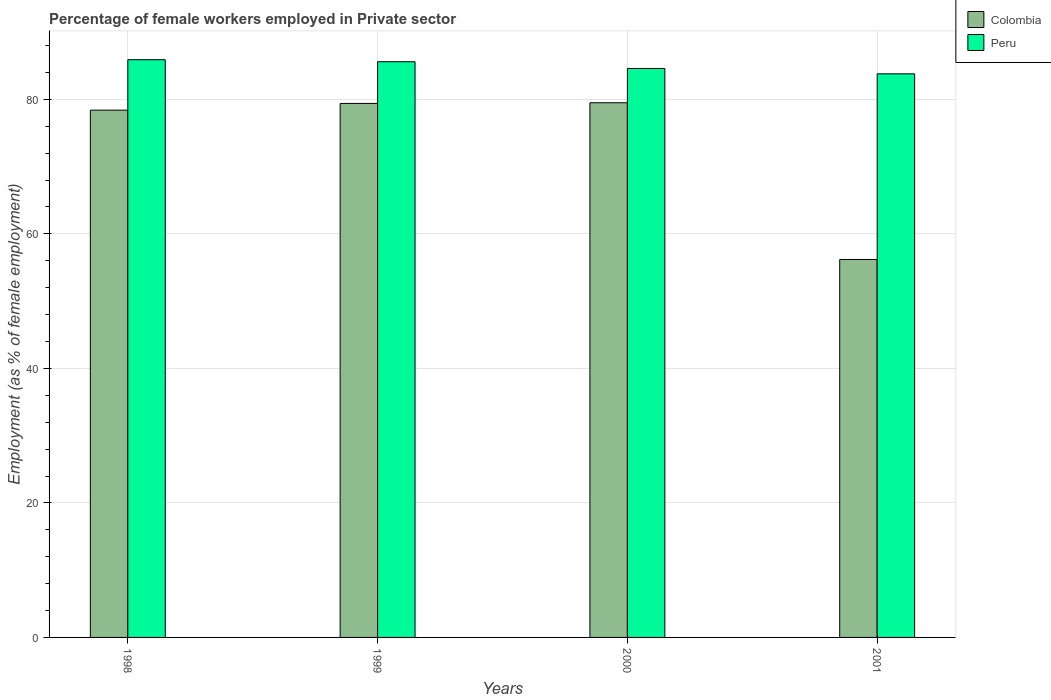How many different coloured bars are there?
Make the answer very short. 2. How many groups of bars are there?
Ensure brevity in your answer.  4. What is the label of the 3rd group of bars from the left?
Offer a very short reply. 2000. What is the percentage of females employed in Private sector in Peru in 2001?
Offer a very short reply. 83.8. Across all years, what is the maximum percentage of females employed in Private sector in Peru?
Offer a terse response. 85.9. Across all years, what is the minimum percentage of females employed in Private sector in Colombia?
Offer a terse response. 56.2. In which year was the percentage of females employed in Private sector in Peru maximum?
Provide a succinct answer. 1998. What is the total percentage of females employed in Private sector in Peru in the graph?
Offer a very short reply. 339.9. What is the difference between the percentage of females employed in Private sector in Colombia in 2000 and that in 2001?
Ensure brevity in your answer.  23.3. What is the difference between the percentage of females employed in Private sector in Colombia in 2001 and the percentage of females employed in Private sector in Peru in 1999?
Provide a succinct answer. -29.4. What is the average percentage of females employed in Private sector in Peru per year?
Give a very brief answer. 84.98. In the year 2000, what is the difference between the percentage of females employed in Private sector in Colombia and percentage of females employed in Private sector in Peru?
Provide a short and direct response. -5.1. In how many years, is the percentage of females employed in Private sector in Peru greater than 24 %?
Provide a short and direct response. 4. What is the ratio of the percentage of females employed in Private sector in Colombia in 1999 to that in 2001?
Give a very brief answer. 1.41. Is the percentage of females employed in Private sector in Colombia in 1999 less than that in 2001?
Provide a succinct answer. No. Is the difference between the percentage of females employed in Private sector in Colombia in 1998 and 2001 greater than the difference between the percentage of females employed in Private sector in Peru in 1998 and 2001?
Your answer should be compact. Yes. What is the difference between the highest and the second highest percentage of females employed in Private sector in Colombia?
Your answer should be compact. 0.1. What is the difference between the highest and the lowest percentage of females employed in Private sector in Colombia?
Offer a very short reply. 23.3. In how many years, is the percentage of females employed in Private sector in Colombia greater than the average percentage of females employed in Private sector in Colombia taken over all years?
Make the answer very short. 3. Is the sum of the percentage of females employed in Private sector in Peru in 2000 and 2001 greater than the maximum percentage of females employed in Private sector in Colombia across all years?
Your answer should be compact. Yes. What does the 2nd bar from the left in 2000 represents?
Offer a very short reply. Peru. How many years are there in the graph?
Provide a short and direct response. 4. How many legend labels are there?
Make the answer very short. 2. What is the title of the graph?
Keep it short and to the point. Percentage of female workers employed in Private sector. Does "Guyana" appear as one of the legend labels in the graph?
Provide a short and direct response. No. What is the label or title of the Y-axis?
Provide a short and direct response. Employment (as % of female employment). What is the Employment (as % of female employment) of Colombia in 1998?
Your answer should be very brief. 78.4. What is the Employment (as % of female employment) in Peru in 1998?
Make the answer very short. 85.9. What is the Employment (as % of female employment) in Colombia in 1999?
Provide a succinct answer. 79.4. What is the Employment (as % of female employment) in Peru in 1999?
Ensure brevity in your answer.  85.6. What is the Employment (as % of female employment) in Colombia in 2000?
Ensure brevity in your answer.  79.5. What is the Employment (as % of female employment) in Peru in 2000?
Provide a short and direct response. 84.6. What is the Employment (as % of female employment) of Colombia in 2001?
Keep it short and to the point. 56.2. What is the Employment (as % of female employment) of Peru in 2001?
Ensure brevity in your answer.  83.8. Across all years, what is the maximum Employment (as % of female employment) in Colombia?
Make the answer very short. 79.5. Across all years, what is the maximum Employment (as % of female employment) of Peru?
Offer a terse response. 85.9. Across all years, what is the minimum Employment (as % of female employment) in Colombia?
Provide a short and direct response. 56.2. Across all years, what is the minimum Employment (as % of female employment) in Peru?
Offer a terse response. 83.8. What is the total Employment (as % of female employment) in Colombia in the graph?
Keep it short and to the point. 293.5. What is the total Employment (as % of female employment) of Peru in the graph?
Your answer should be very brief. 339.9. What is the difference between the Employment (as % of female employment) in Peru in 1998 and that in 1999?
Give a very brief answer. 0.3. What is the difference between the Employment (as % of female employment) in Peru in 1998 and that in 2001?
Offer a very short reply. 2.1. What is the difference between the Employment (as % of female employment) in Colombia in 1999 and that in 2000?
Your answer should be compact. -0.1. What is the difference between the Employment (as % of female employment) in Peru in 1999 and that in 2000?
Offer a very short reply. 1. What is the difference between the Employment (as % of female employment) in Colombia in 1999 and that in 2001?
Provide a succinct answer. 23.2. What is the difference between the Employment (as % of female employment) of Colombia in 2000 and that in 2001?
Provide a succinct answer. 23.3. What is the difference between the Employment (as % of female employment) in Colombia in 1998 and the Employment (as % of female employment) in Peru in 2000?
Give a very brief answer. -6.2. What is the difference between the Employment (as % of female employment) of Colombia in 1998 and the Employment (as % of female employment) of Peru in 2001?
Offer a terse response. -5.4. What is the difference between the Employment (as % of female employment) of Colombia in 1999 and the Employment (as % of female employment) of Peru in 2001?
Keep it short and to the point. -4.4. What is the average Employment (as % of female employment) in Colombia per year?
Offer a very short reply. 73.38. What is the average Employment (as % of female employment) of Peru per year?
Your response must be concise. 84.97. In the year 1998, what is the difference between the Employment (as % of female employment) in Colombia and Employment (as % of female employment) in Peru?
Keep it short and to the point. -7.5. In the year 2000, what is the difference between the Employment (as % of female employment) of Colombia and Employment (as % of female employment) of Peru?
Ensure brevity in your answer.  -5.1. In the year 2001, what is the difference between the Employment (as % of female employment) of Colombia and Employment (as % of female employment) of Peru?
Ensure brevity in your answer.  -27.6. What is the ratio of the Employment (as % of female employment) of Colombia in 1998 to that in 1999?
Offer a terse response. 0.99. What is the ratio of the Employment (as % of female employment) of Colombia in 1998 to that in 2000?
Offer a terse response. 0.99. What is the ratio of the Employment (as % of female employment) in Peru in 1998 to that in 2000?
Provide a succinct answer. 1.02. What is the ratio of the Employment (as % of female employment) in Colombia in 1998 to that in 2001?
Your response must be concise. 1.4. What is the ratio of the Employment (as % of female employment) of Peru in 1998 to that in 2001?
Provide a short and direct response. 1.03. What is the ratio of the Employment (as % of female employment) in Colombia in 1999 to that in 2000?
Your answer should be very brief. 1. What is the ratio of the Employment (as % of female employment) of Peru in 1999 to that in 2000?
Ensure brevity in your answer.  1.01. What is the ratio of the Employment (as % of female employment) of Colombia in 1999 to that in 2001?
Offer a terse response. 1.41. What is the ratio of the Employment (as % of female employment) in Peru in 1999 to that in 2001?
Provide a succinct answer. 1.02. What is the ratio of the Employment (as % of female employment) of Colombia in 2000 to that in 2001?
Make the answer very short. 1.41. What is the ratio of the Employment (as % of female employment) of Peru in 2000 to that in 2001?
Keep it short and to the point. 1.01. What is the difference between the highest and the second highest Employment (as % of female employment) in Colombia?
Your answer should be compact. 0.1. What is the difference between the highest and the lowest Employment (as % of female employment) of Colombia?
Ensure brevity in your answer.  23.3. 